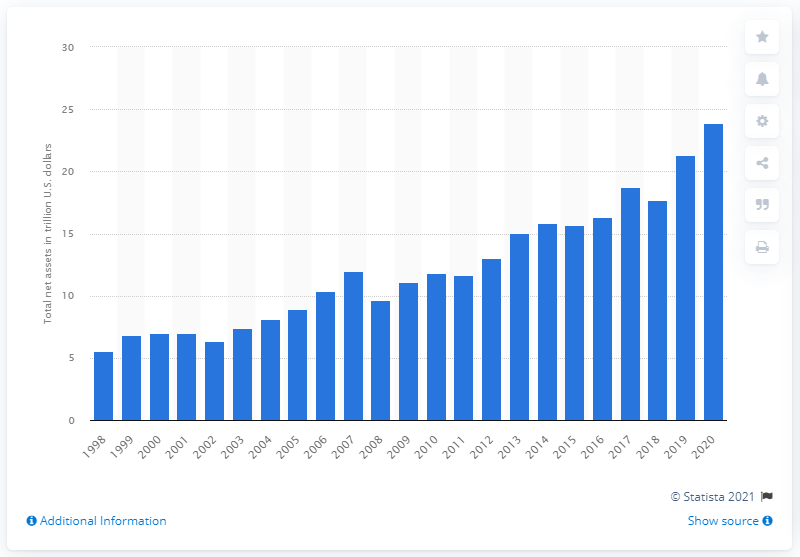Identify some key points in this picture. As of 2020, the total global net assets of mutual funds registered in the United States were approximately 23.9 trillion dollars. 